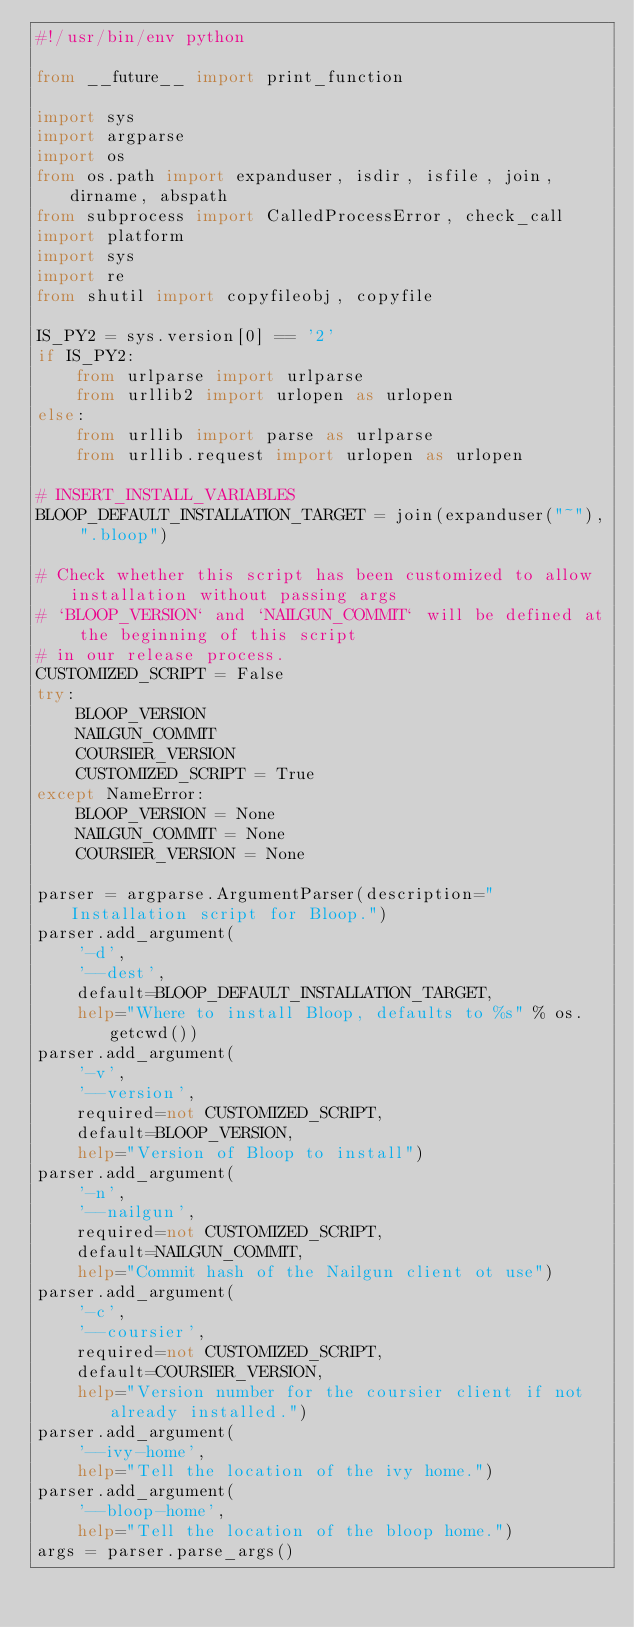<code> <loc_0><loc_0><loc_500><loc_500><_Python_>#!/usr/bin/env python

from __future__ import print_function

import sys
import argparse
import os
from os.path import expanduser, isdir, isfile, join, dirname, abspath
from subprocess import CalledProcessError, check_call
import platform
import sys
import re
from shutil import copyfileobj, copyfile

IS_PY2 = sys.version[0] == '2'
if IS_PY2:
    from urlparse import urlparse
    from urllib2 import urlopen as urlopen
else:
    from urllib import parse as urlparse
    from urllib.request import urlopen as urlopen

# INSERT_INSTALL_VARIABLES
BLOOP_DEFAULT_INSTALLATION_TARGET = join(expanduser("~"), ".bloop")

# Check whether this script has been customized to allow installation without passing args
# `BLOOP_VERSION` and `NAILGUN_COMMIT` will be defined at the beginning of this script
# in our release process.
CUSTOMIZED_SCRIPT = False
try:
    BLOOP_VERSION
    NAILGUN_COMMIT
    COURSIER_VERSION
    CUSTOMIZED_SCRIPT = True
except NameError:
    BLOOP_VERSION = None
    NAILGUN_COMMIT = None
    COURSIER_VERSION = None

parser = argparse.ArgumentParser(description="Installation script for Bloop.")
parser.add_argument(
    '-d',
    '--dest',
    default=BLOOP_DEFAULT_INSTALLATION_TARGET,
    help="Where to install Bloop, defaults to %s" % os.getcwd())
parser.add_argument(
    '-v',
    '--version',
    required=not CUSTOMIZED_SCRIPT,
    default=BLOOP_VERSION,
    help="Version of Bloop to install")
parser.add_argument(
    '-n',
    '--nailgun',
    required=not CUSTOMIZED_SCRIPT,
    default=NAILGUN_COMMIT,
    help="Commit hash of the Nailgun client ot use")
parser.add_argument(
    '-c',
    '--coursier',
    required=not CUSTOMIZED_SCRIPT,
    default=COURSIER_VERSION,
    help="Version number for the coursier client if not already installed.")
parser.add_argument(
    '--ivy-home',
    help="Tell the location of the ivy home.")
parser.add_argument(
    '--bloop-home',
    help="Tell the location of the bloop home.")
args = parser.parse_args()</code> 